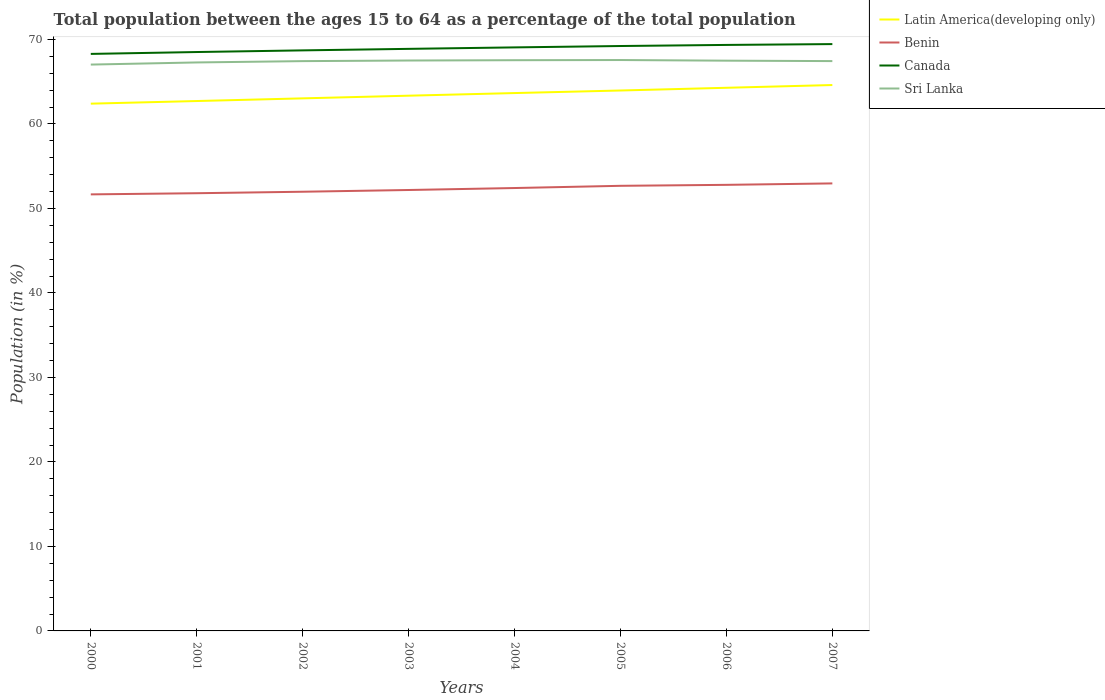Is the number of lines equal to the number of legend labels?
Your response must be concise. Yes. Across all years, what is the maximum percentage of the population ages 15 to 64 in Sri Lanka?
Make the answer very short. 67.02. What is the total percentage of the population ages 15 to 64 in Latin America(developing only) in the graph?
Offer a very short reply. -1.57. What is the difference between the highest and the second highest percentage of the population ages 15 to 64 in Latin America(developing only)?
Give a very brief answer. 2.2. What is the difference between the highest and the lowest percentage of the population ages 15 to 64 in Sri Lanka?
Your answer should be compact. 6. Is the percentage of the population ages 15 to 64 in Sri Lanka strictly greater than the percentage of the population ages 15 to 64 in Benin over the years?
Ensure brevity in your answer.  No. What is the difference between two consecutive major ticks on the Y-axis?
Offer a terse response. 10. Are the values on the major ticks of Y-axis written in scientific E-notation?
Make the answer very short. No. How are the legend labels stacked?
Your answer should be very brief. Vertical. What is the title of the graph?
Provide a succinct answer. Total population between the ages 15 to 64 as a percentage of the total population. Does "Suriname" appear as one of the legend labels in the graph?
Your answer should be very brief. No. What is the Population (in %) of Latin America(developing only) in 2000?
Your answer should be compact. 62.4. What is the Population (in %) in Benin in 2000?
Provide a succinct answer. 51.66. What is the Population (in %) in Canada in 2000?
Offer a very short reply. 68.28. What is the Population (in %) in Sri Lanka in 2000?
Provide a short and direct response. 67.02. What is the Population (in %) in Latin America(developing only) in 2001?
Your answer should be very brief. 62.71. What is the Population (in %) of Benin in 2001?
Your answer should be very brief. 51.8. What is the Population (in %) in Canada in 2001?
Provide a short and direct response. 68.51. What is the Population (in %) in Sri Lanka in 2001?
Ensure brevity in your answer.  67.28. What is the Population (in %) of Latin America(developing only) in 2002?
Provide a succinct answer. 63.02. What is the Population (in %) in Benin in 2002?
Provide a succinct answer. 51.97. What is the Population (in %) in Canada in 2002?
Give a very brief answer. 68.7. What is the Population (in %) of Sri Lanka in 2002?
Keep it short and to the point. 67.43. What is the Population (in %) in Latin America(developing only) in 2003?
Give a very brief answer. 63.34. What is the Population (in %) in Benin in 2003?
Give a very brief answer. 52.18. What is the Population (in %) of Canada in 2003?
Your answer should be compact. 68.88. What is the Population (in %) of Sri Lanka in 2003?
Your answer should be very brief. 67.5. What is the Population (in %) of Latin America(developing only) in 2004?
Provide a succinct answer. 63.65. What is the Population (in %) in Benin in 2004?
Provide a succinct answer. 52.41. What is the Population (in %) of Canada in 2004?
Provide a succinct answer. 69.06. What is the Population (in %) of Sri Lanka in 2004?
Your answer should be very brief. 67.54. What is the Population (in %) of Latin America(developing only) in 2005?
Provide a succinct answer. 63.96. What is the Population (in %) in Benin in 2005?
Provide a succinct answer. 52.67. What is the Population (in %) of Canada in 2005?
Your response must be concise. 69.22. What is the Population (in %) of Sri Lanka in 2005?
Ensure brevity in your answer.  67.56. What is the Population (in %) of Latin America(developing only) in 2006?
Your answer should be compact. 64.28. What is the Population (in %) in Benin in 2006?
Ensure brevity in your answer.  52.79. What is the Population (in %) in Canada in 2006?
Ensure brevity in your answer.  69.35. What is the Population (in %) of Sri Lanka in 2006?
Make the answer very short. 67.48. What is the Population (in %) in Latin America(developing only) in 2007?
Ensure brevity in your answer.  64.6. What is the Population (in %) in Benin in 2007?
Provide a short and direct response. 52.96. What is the Population (in %) of Canada in 2007?
Offer a very short reply. 69.45. What is the Population (in %) of Sri Lanka in 2007?
Your answer should be compact. 67.43. Across all years, what is the maximum Population (in %) in Latin America(developing only)?
Offer a very short reply. 64.6. Across all years, what is the maximum Population (in %) of Benin?
Your answer should be very brief. 52.96. Across all years, what is the maximum Population (in %) in Canada?
Ensure brevity in your answer.  69.45. Across all years, what is the maximum Population (in %) in Sri Lanka?
Give a very brief answer. 67.56. Across all years, what is the minimum Population (in %) in Latin America(developing only)?
Your answer should be compact. 62.4. Across all years, what is the minimum Population (in %) of Benin?
Your response must be concise. 51.66. Across all years, what is the minimum Population (in %) in Canada?
Make the answer very short. 68.28. Across all years, what is the minimum Population (in %) in Sri Lanka?
Give a very brief answer. 67.02. What is the total Population (in %) in Latin America(developing only) in the graph?
Your answer should be very brief. 507.96. What is the total Population (in %) in Benin in the graph?
Offer a terse response. 418.45. What is the total Population (in %) in Canada in the graph?
Make the answer very short. 551.44. What is the total Population (in %) of Sri Lanka in the graph?
Offer a very short reply. 539.25. What is the difference between the Population (in %) in Latin America(developing only) in 2000 and that in 2001?
Keep it short and to the point. -0.31. What is the difference between the Population (in %) of Benin in 2000 and that in 2001?
Make the answer very short. -0.14. What is the difference between the Population (in %) of Canada in 2000 and that in 2001?
Offer a very short reply. -0.22. What is the difference between the Population (in %) in Sri Lanka in 2000 and that in 2001?
Provide a short and direct response. -0.25. What is the difference between the Population (in %) of Latin America(developing only) in 2000 and that in 2002?
Make the answer very short. -0.63. What is the difference between the Population (in %) of Benin in 2000 and that in 2002?
Your response must be concise. -0.31. What is the difference between the Population (in %) in Canada in 2000 and that in 2002?
Keep it short and to the point. -0.42. What is the difference between the Population (in %) in Sri Lanka in 2000 and that in 2002?
Provide a short and direct response. -0.41. What is the difference between the Population (in %) of Latin America(developing only) in 2000 and that in 2003?
Your answer should be compact. -0.94. What is the difference between the Population (in %) of Benin in 2000 and that in 2003?
Offer a terse response. -0.52. What is the difference between the Population (in %) of Canada in 2000 and that in 2003?
Offer a terse response. -0.6. What is the difference between the Population (in %) in Sri Lanka in 2000 and that in 2003?
Provide a succinct answer. -0.48. What is the difference between the Population (in %) in Latin America(developing only) in 2000 and that in 2004?
Your response must be concise. -1.25. What is the difference between the Population (in %) of Benin in 2000 and that in 2004?
Offer a terse response. -0.75. What is the difference between the Population (in %) in Canada in 2000 and that in 2004?
Your answer should be very brief. -0.77. What is the difference between the Population (in %) of Sri Lanka in 2000 and that in 2004?
Give a very brief answer. -0.52. What is the difference between the Population (in %) of Latin America(developing only) in 2000 and that in 2005?
Your answer should be very brief. -1.56. What is the difference between the Population (in %) in Benin in 2000 and that in 2005?
Your answer should be compact. -1.01. What is the difference between the Population (in %) in Canada in 2000 and that in 2005?
Your response must be concise. -0.93. What is the difference between the Population (in %) of Sri Lanka in 2000 and that in 2005?
Provide a succinct answer. -0.54. What is the difference between the Population (in %) in Latin America(developing only) in 2000 and that in 2006?
Give a very brief answer. -1.88. What is the difference between the Population (in %) in Benin in 2000 and that in 2006?
Give a very brief answer. -1.13. What is the difference between the Population (in %) in Canada in 2000 and that in 2006?
Make the answer very short. -1.06. What is the difference between the Population (in %) in Sri Lanka in 2000 and that in 2006?
Your answer should be compact. -0.46. What is the difference between the Population (in %) in Latin America(developing only) in 2000 and that in 2007?
Offer a terse response. -2.2. What is the difference between the Population (in %) in Benin in 2000 and that in 2007?
Make the answer very short. -1.3. What is the difference between the Population (in %) of Canada in 2000 and that in 2007?
Give a very brief answer. -1.16. What is the difference between the Population (in %) of Sri Lanka in 2000 and that in 2007?
Provide a succinct answer. -0.41. What is the difference between the Population (in %) of Latin America(developing only) in 2001 and that in 2002?
Provide a short and direct response. -0.32. What is the difference between the Population (in %) in Benin in 2001 and that in 2002?
Keep it short and to the point. -0.17. What is the difference between the Population (in %) of Canada in 2001 and that in 2002?
Your answer should be compact. -0.2. What is the difference between the Population (in %) in Sri Lanka in 2001 and that in 2002?
Give a very brief answer. -0.15. What is the difference between the Population (in %) in Latin America(developing only) in 2001 and that in 2003?
Keep it short and to the point. -0.63. What is the difference between the Population (in %) in Benin in 2001 and that in 2003?
Your response must be concise. -0.38. What is the difference between the Population (in %) of Canada in 2001 and that in 2003?
Offer a very short reply. -0.37. What is the difference between the Population (in %) in Sri Lanka in 2001 and that in 2003?
Offer a terse response. -0.23. What is the difference between the Population (in %) in Latin America(developing only) in 2001 and that in 2004?
Offer a terse response. -0.94. What is the difference between the Population (in %) of Benin in 2001 and that in 2004?
Keep it short and to the point. -0.61. What is the difference between the Population (in %) of Canada in 2001 and that in 2004?
Your answer should be compact. -0.55. What is the difference between the Population (in %) of Sri Lanka in 2001 and that in 2004?
Keep it short and to the point. -0.26. What is the difference between the Population (in %) of Latin America(developing only) in 2001 and that in 2005?
Make the answer very short. -1.25. What is the difference between the Population (in %) of Benin in 2001 and that in 2005?
Your answer should be compact. -0.88. What is the difference between the Population (in %) in Canada in 2001 and that in 2005?
Give a very brief answer. -0.71. What is the difference between the Population (in %) of Sri Lanka in 2001 and that in 2005?
Provide a short and direct response. -0.28. What is the difference between the Population (in %) in Latin America(developing only) in 2001 and that in 2006?
Make the answer very short. -1.57. What is the difference between the Population (in %) of Benin in 2001 and that in 2006?
Your response must be concise. -0.99. What is the difference between the Population (in %) of Canada in 2001 and that in 2006?
Give a very brief answer. -0.84. What is the difference between the Population (in %) of Sri Lanka in 2001 and that in 2006?
Offer a very short reply. -0.21. What is the difference between the Population (in %) in Latin America(developing only) in 2001 and that in 2007?
Ensure brevity in your answer.  -1.89. What is the difference between the Population (in %) in Benin in 2001 and that in 2007?
Your response must be concise. -1.16. What is the difference between the Population (in %) in Canada in 2001 and that in 2007?
Give a very brief answer. -0.94. What is the difference between the Population (in %) in Sri Lanka in 2001 and that in 2007?
Give a very brief answer. -0.16. What is the difference between the Population (in %) in Latin America(developing only) in 2002 and that in 2003?
Your answer should be very brief. -0.32. What is the difference between the Population (in %) in Benin in 2002 and that in 2003?
Your answer should be compact. -0.2. What is the difference between the Population (in %) in Canada in 2002 and that in 2003?
Keep it short and to the point. -0.18. What is the difference between the Population (in %) in Sri Lanka in 2002 and that in 2003?
Offer a very short reply. -0.07. What is the difference between the Population (in %) of Latin America(developing only) in 2002 and that in 2004?
Your answer should be compact. -0.63. What is the difference between the Population (in %) in Benin in 2002 and that in 2004?
Your response must be concise. -0.44. What is the difference between the Population (in %) in Canada in 2002 and that in 2004?
Make the answer very short. -0.35. What is the difference between the Population (in %) in Sri Lanka in 2002 and that in 2004?
Your answer should be very brief. -0.11. What is the difference between the Population (in %) in Latin America(developing only) in 2002 and that in 2005?
Your answer should be compact. -0.93. What is the difference between the Population (in %) of Benin in 2002 and that in 2005?
Provide a succinct answer. -0.7. What is the difference between the Population (in %) of Canada in 2002 and that in 2005?
Your answer should be very brief. -0.52. What is the difference between the Population (in %) of Sri Lanka in 2002 and that in 2005?
Provide a succinct answer. -0.13. What is the difference between the Population (in %) in Latin America(developing only) in 2002 and that in 2006?
Provide a short and direct response. -1.25. What is the difference between the Population (in %) of Benin in 2002 and that in 2006?
Make the answer very short. -0.82. What is the difference between the Population (in %) of Canada in 2002 and that in 2006?
Your answer should be compact. -0.64. What is the difference between the Population (in %) of Sri Lanka in 2002 and that in 2006?
Provide a succinct answer. -0.05. What is the difference between the Population (in %) of Latin America(developing only) in 2002 and that in 2007?
Provide a short and direct response. -1.58. What is the difference between the Population (in %) of Benin in 2002 and that in 2007?
Your answer should be compact. -0.99. What is the difference between the Population (in %) of Canada in 2002 and that in 2007?
Keep it short and to the point. -0.74. What is the difference between the Population (in %) in Sri Lanka in 2002 and that in 2007?
Offer a terse response. -0. What is the difference between the Population (in %) in Latin America(developing only) in 2003 and that in 2004?
Ensure brevity in your answer.  -0.31. What is the difference between the Population (in %) in Benin in 2003 and that in 2004?
Provide a short and direct response. -0.23. What is the difference between the Population (in %) in Canada in 2003 and that in 2004?
Provide a succinct answer. -0.17. What is the difference between the Population (in %) of Sri Lanka in 2003 and that in 2004?
Ensure brevity in your answer.  -0.04. What is the difference between the Population (in %) in Latin America(developing only) in 2003 and that in 2005?
Offer a very short reply. -0.61. What is the difference between the Population (in %) in Benin in 2003 and that in 2005?
Give a very brief answer. -0.5. What is the difference between the Population (in %) of Canada in 2003 and that in 2005?
Ensure brevity in your answer.  -0.34. What is the difference between the Population (in %) of Sri Lanka in 2003 and that in 2005?
Your answer should be compact. -0.06. What is the difference between the Population (in %) in Latin America(developing only) in 2003 and that in 2006?
Provide a short and direct response. -0.94. What is the difference between the Population (in %) in Benin in 2003 and that in 2006?
Offer a very short reply. -0.61. What is the difference between the Population (in %) in Canada in 2003 and that in 2006?
Give a very brief answer. -0.47. What is the difference between the Population (in %) of Sri Lanka in 2003 and that in 2006?
Your answer should be very brief. 0.02. What is the difference between the Population (in %) of Latin America(developing only) in 2003 and that in 2007?
Your answer should be compact. -1.26. What is the difference between the Population (in %) in Benin in 2003 and that in 2007?
Provide a short and direct response. -0.78. What is the difference between the Population (in %) of Canada in 2003 and that in 2007?
Provide a short and direct response. -0.57. What is the difference between the Population (in %) of Sri Lanka in 2003 and that in 2007?
Your response must be concise. 0.07. What is the difference between the Population (in %) of Latin America(developing only) in 2004 and that in 2005?
Ensure brevity in your answer.  -0.3. What is the difference between the Population (in %) of Benin in 2004 and that in 2005?
Offer a very short reply. -0.26. What is the difference between the Population (in %) of Canada in 2004 and that in 2005?
Offer a terse response. -0.16. What is the difference between the Population (in %) in Sri Lanka in 2004 and that in 2005?
Keep it short and to the point. -0.02. What is the difference between the Population (in %) in Latin America(developing only) in 2004 and that in 2006?
Your answer should be compact. -0.63. What is the difference between the Population (in %) in Benin in 2004 and that in 2006?
Give a very brief answer. -0.38. What is the difference between the Population (in %) in Canada in 2004 and that in 2006?
Provide a short and direct response. -0.29. What is the difference between the Population (in %) of Sri Lanka in 2004 and that in 2006?
Keep it short and to the point. 0.06. What is the difference between the Population (in %) of Latin America(developing only) in 2004 and that in 2007?
Make the answer very short. -0.95. What is the difference between the Population (in %) of Benin in 2004 and that in 2007?
Offer a very short reply. -0.55. What is the difference between the Population (in %) in Canada in 2004 and that in 2007?
Offer a very short reply. -0.39. What is the difference between the Population (in %) of Sri Lanka in 2004 and that in 2007?
Your response must be concise. 0.11. What is the difference between the Population (in %) in Latin America(developing only) in 2005 and that in 2006?
Your answer should be compact. -0.32. What is the difference between the Population (in %) of Benin in 2005 and that in 2006?
Your answer should be compact. -0.12. What is the difference between the Population (in %) in Canada in 2005 and that in 2006?
Give a very brief answer. -0.13. What is the difference between the Population (in %) of Sri Lanka in 2005 and that in 2006?
Your answer should be very brief. 0.08. What is the difference between the Population (in %) in Latin America(developing only) in 2005 and that in 2007?
Give a very brief answer. -0.65. What is the difference between the Population (in %) of Benin in 2005 and that in 2007?
Make the answer very short. -0.28. What is the difference between the Population (in %) of Canada in 2005 and that in 2007?
Offer a terse response. -0.23. What is the difference between the Population (in %) of Sri Lanka in 2005 and that in 2007?
Provide a succinct answer. 0.13. What is the difference between the Population (in %) in Latin America(developing only) in 2006 and that in 2007?
Ensure brevity in your answer.  -0.32. What is the difference between the Population (in %) of Benin in 2006 and that in 2007?
Your answer should be very brief. -0.17. What is the difference between the Population (in %) of Canada in 2006 and that in 2007?
Ensure brevity in your answer.  -0.1. What is the difference between the Population (in %) in Sri Lanka in 2006 and that in 2007?
Make the answer very short. 0.05. What is the difference between the Population (in %) of Latin America(developing only) in 2000 and the Population (in %) of Benin in 2001?
Offer a terse response. 10.6. What is the difference between the Population (in %) of Latin America(developing only) in 2000 and the Population (in %) of Canada in 2001?
Your answer should be very brief. -6.11. What is the difference between the Population (in %) in Latin America(developing only) in 2000 and the Population (in %) in Sri Lanka in 2001?
Make the answer very short. -4.88. What is the difference between the Population (in %) in Benin in 2000 and the Population (in %) in Canada in 2001?
Your response must be concise. -16.85. What is the difference between the Population (in %) of Benin in 2000 and the Population (in %) of Sri Lanka in 2001?
Your response must be concise. -15.61. What is the difference between the Population (in %) of Canada in 2000 and the Population (in %) of Sri Lanka in 2001?
Provide a succinct answer. 1.01. What is the difference between the Population (in %) in Latin America(developing only) in 2000 and the Population (in %) in Benin in 2002?
Ensure brevity in your answer.  10.42. What is the difference between the Population (in %) in Latin America(developing only) in 2000 and the Population (in %) in Canada in 2002?
Make the answer very short. -6.3. What is the difference between the Population (in %) of Latin America(developing only) in 2000 and the Population (in %) of Sri Lanka in 2002?
Your answer should be compact. -5.03. What is the difference between the Population (in %) in Benin in 2000 and the Population (in %) in Canada in 2002?
Keep it short and to the point. -17.04. What is the difference between the Population (in %) of Benin in 2000 and the Population (in %) of Sri Lanka in 2002?
Give a very brief answer. -15.77. What is the difference between the Population (in %) of Canada in 2000 and the Population (in %) of Sri Lanka in 2002?
Ensure brevity in your answer.  0.85. What is the difference between the Population (in %) in Latin America(developing only) in 2000 and the Population (in %) in Benin in 2003?
Your answer should be compact. 10.22. What is the difference between the Population (in %) in Latin America(developing only) in 2000 and the Population (in %) in Canada in 2003?
Make the answer very short. -6.48. What is the difference between the Population (in %) of Latin America(developing only) in 2000 and the Population (in %) of Sri Lanka in 2003?
Ensure brevity in your answer.  -5.11. What is the difference between the Population (in %) of Benin in 2000 and the Population (in %) of Canada in 2003?
Make the answer very short. -17.22. What is the difference between the Population (in %) of Benin in 2000 and the Population (in %) of Sri Lanka in 2003?
Give a very brief answer. -15.84. What is the difference between the Population (in %) in Canada in 2000 and the Population (in %) in Sri Lanka in 2003?
Your response must be concise. 0.78. What is the difference between the Population (in %) of Latin America(developing only) in 2000 and the Population (in %) of Benin in 2004?
Your answer should be very brief. 9.99. What is the difference between the Population (in %) of Latin America(developing only) in 2000 and the Population (in %) of Canada in 2004?
Give a very brief answer. -6.66. What is the difference between the Population (in %) of Latin America(developing only) in 2000 and the Population (in %) of Sri Lanka in 2004?
Provide a short and direct response. -5.14. What is the difference between the Population (in %) of Benin in 2000 and the Population (in %) of Canada in 2004?
Offer a very short reply. -17.39. What is the difference between the Population (in %) in Benin in 2000 and the Population (in %) in Sri Lanka in 2004?
Offer a very short reply. -15.88. What is the difference between the Population (in %) in Canada in 2000 and the Population (in %) in Sri Lanka in 2004?
Keep it short and to the point. 0.74. What is the difference between the Population (in %) in Latin America(developing only) in 2000 and the Population (in %) in Benin in 2005?
Give a very brief answer. 9.72. What is the difference between the Population (in %) of Latin America(developing only) in 2000 and the Population (in %) of Canada in 2005?
Make the answer very short. -6.82. What is the difference between the Population (in %) in Latin America(developing only) in 2000 and the Population (in %) in Sri Lanka in 2005?
Give a very brief answer. -5.16. What is the difference between the Population (in %) in Benin in 2000 and the Population (in %) in Canada in 2005?
Ensure brevity in your answer.  -17.56. What is the difference between the Population (in %) of Benin in 2000 and the Population (in %) of Sri Lanka in 2005?
Ensure brevity in your answer.  -15.9. What is the difference between the Population (in %) in Canada in 2000 and the Population (in %) in Sri Lanka in 2005?
Keep it short and to the point. 0.72. What is the difference between the Population (in %) in Latin America(developing only) in 2000 and the Population (in %) in Benin in 2006?
Ensure brevity in your answer.  9.61. What is the difference between the Population (in %) in Latin America(developing only) in 2000 and the Population (in %) in Canada in 2006?
Keep it short and to the point. -6.95. What is the difference between the Population (in %) in Latin America(developing only) in 2000 and the Population (in %) in Sri Lanka in 2006?
Offer a very short reply. -5.09. What is the difference between the Population (in %) of Benin in 2000 and the Population (in %) of Canada in 2006?
Make the answer very short. -17.69. What is the difference between the Population (in %) in Benin in 2000 and the Population (in %) in Sri Lanka in 2006?
Ensure brevity in your answer.  -15.82. What is the difference between the Population (in %) in Latin America(developing only) in 2000 and the Population (in %) in Benin in 2007?
Your answer should be compact. 9.44. What is the difference between the Population (in %) of Latin America(developing only) in 2000 and the Population (in %) of Canada in 2007?
Give a very brief answer. -7.05. What is the difference between the Population (in %) of Latin America(developing only) in 2000 and the Population (in %) of Sri Lanka in 2007?
Ensure brevity in your answer.  -5.04. What is the difference between the Population (in %) in Benin in 2000 and the Population (in %) in Canada in 2007?
Provide a short and direct response. -17.79. What is the difference between the Population (in %) of Benin in 2000 and the Population (in %) of Sri Lanka in 2007?
Keep it short and to the point. -15.77. What is the difference between the Population (in %) of Canada in 2000 and the Population (in %) of Sri Lanka in 2007?
Keep it short and to the point. 0.85. What is the difference between the Population (in %) of Latin America(developing only) in 2001 and the Population (in %) of Benin in 2002?
Keep it short and to the point. 10.73. What is the difference between the Population (in %) of Latin America(developing only) in 2001 and the Population (in %) of Canada in 2002?
Your answer should be very brief. -6. What is the difference between the Population (in %) in Latin America(developing only) in 2001 and the Population (in %) in Sri Lanka in 2002?
Ensure brevity in your answer.  -4.72. What is the difference between the Population (in %) in Benin in 2001 and the Population (in %) in Canada in 2002?
Keep it short and to the point. -16.9. What is the difference between the Population (in %) in Benin in 2001 and the Population (in %) in Sri Lanka in 2002?
Your response must be concise. -15.63. What is the difference between the Population (in %) in Canada in 2001 and the Population (in %) in Sri Lanka in 2002?
Offer a very short reply. 1.08. What is the difference between the Population (in %) in Latin America(developing only) in 2001 and the Population (in %) in Benin in 2003?
Your response must be concise. 10.53. What is the difference between the Population (in %) of Latin America(developing only) in 2001 and the Population (in %) of Canada in 2003?
Keep it short and to the point. -6.17. What is the difference between the Population (in %) in Latin America(developing only) in 2001 and the Population (in %) in Sri Lanka in 2003?
Make the answer very short. -4.8. What is the difference between the Population (in %) in Benin in 2001 and the Population (in %) in Canada in 2003?
Provide a short and direct response. -17.08. What is the difference between the Population (in %) in Benin in 2001 and the Population (in %) in Sri Lanka in 2003?
Your response must be concise. -15.7. What is the difference between the Population (in %) in Latin America(developing only) in 2001 and the Population (in %) in Benin in 2004?
Provide a succinct answer. 10.3. What is the difference between the Population (in %) in Latin America(developing only) in 2001 and the Population (in %) in Canada in 2004?
Your answer should be compact. -6.35. What is the difference between the Population (in %) in Latin America(developing only) in 2001 and the Population (in %) in Sri Lanka in 2004?
Ensure brevity in your answer.  -4.83. What is the difference between the Population (in %) of Benin in 2001 and the Population (in %) of Canada in 2004?
Your answer should be compact. -17.26. What is the difference between the Population (in %) of Benin in 2001 and the Population (in %) of Sri Lanka in 2004?
Keep it short and to the point. -15.74. What is the difference between the Population (in %) in Canada in 2001 and the Population (in %) in Sri Lanka in 2004?
Offer a very short reply. 0.97. What is the difference between the Population (in %) in Latin America(developing only) in 2001 and the Population (in %) in Benin in 2005?
Your response must be concise. 10.03. What is the difference between the Population (in %) in Latin America(developing only) in 2001 and the Population (in %) in Canada in 2005?
Give a very brief answer. -6.51. What is the difference between the Population (in %) in Latin America(developing only) in 2001 and the Population (in %) in Sri Lanka in 2005?
Ensure brevity in your answer.  -4.85. What is the difference between the Population (in %) of Benin in 2001 and the Population (in %) of Canada in 2005?
Offer a terse response. -17.42. What is the difference between the Population (in %) in Benin in 2001 and the Population (in %) in Sri Lanka in 2005?
Provide a short and direct response. -15.76. What is the difference between the Population (in %) of Canada in 2001 and the Population (in %) of Sri Lanka in 2005?
Ensure brevity in your answer.  0.95. What is the difference between the Population (in %) of Latin America(developing only) in 2001 and the Population (in %) of Benin in 2006?
Ensure brevity in your answer.  9.92. What is the difference between the Population (in %) of Latin America(developing only) in 2001 and the Population (in %) of Canada in 2006?
Your answer should be compact. -6.64. What is the difference between the Population (in %) of Latin America(developing only) in 2001 and the Population (in %) of Sri Lanka in 2006?
Your response must be concise. -4.78. What is the difference between the Population (in %) in Benin in 2001 and the Population (in %) in Canada in 2006?
Ensure brevity in your answer.  -17.55. What is the difference between the Population (in %) in Benin in 2001 and the Population (in %) in Sri Lanka in 2006?
Provide a short and direct response. -15.68. What is the difference between the Population (in %) in Canada in 2001 and the Population (in %) in Sri Lanka in 2006?
Your answer should be very brief. 1.02. What is the difference between the Population (in %) in Latin America(developing only) in 2001 and the Population (in %) in Benin in 2007?
Your response must be concise. 9.75. What is the difference between the Population (in %) of Latin America(developing only) in 2001 and the Population (in %) of Canada in 2007?
Your answer should be very brief. -6.74. What is the difference between the Population (in %) in Latin America(developing only) in 2001 and the Population (in %) in Sri Lanka in 2007?
Ensure brevity in your answer.  -4.73. What is the difference between the Population (in %) of Benin in 2001 and the Population (in %) of Canada in 2007?
Offer a terse response. -17.65. What is the difference between the Population (in %) of Benin in 2001 and the Population (in %) of Sri Lanka in 2007?
Offer a terse response. -15.63. What is the difference between the Population (in %) of Canada in 2001 and the Population (in %) of Sri Lanka in 2007?
Keep it short and to the point. 1.07. What is the difference between the Population (in %) of Latin America(developing only) in 2002 and the Population (in %) of Benin in 2003?
Offer a terse response. 10.85. What is the difference between the Population (in %) in Latin America(developing only) in 2002 and the Population (in %) in Canada in 2003?
Keep it short and to the point. -5.86. What is the difference between the Population (in %) in Latin America(developing only) in 2002 and the Population (in %) in Sri Lanka in 2003?
Your response must be concise. -4.48. What is the difference between the Population (in %) of Benin in 2002 and the Population (in %) of Canada in 2003?
Offer a very short reply. -16.91. What is the difference between the Population (in %) in Benin in 2002 and the Population (in %) in Sri Lanka in 2003?
Your answer should be compact. -15.53. What is the difference between the Population (in %) of Canada in 2002 and the Population (in %) of Sri Lanka in 2003?
Offer a terse response. 1.2. What is the difference between the Population (in %) in Latin America(developing only) in 2002 and the Population (in %) in Benin in 2004?
Your answer should be very brief. 10.61. What is the difference between the Population (in %) in Latin America(developing only) in 2002 and the Population (in %) in Canada in 2004?
Make the answer very short. -6.03. What is the difference between the Population (in %) of Latin America(developing only) in 2002 and the Population (in %) of Sri Lanka in 2004?
Your answer should be very brief. -4.52. What is the difference between the Population (in %) in Benin in 2002 and the Population (in %) in Canada in 2004?
Offer a very short reply. -17.08. What is the difference between the Population (in %) in Benin in 2002 and the Population (in %) in Sri Lanka in 2004?
Your answer should be compact. -15.57. What is the difference between the Population (in %) in Canada in 2002 and the Population (in %) in Sri Lanka in 2004?
Provide a short and direct response. 1.16. What is the difference between the Population (in %) in Latin America(developing only) in 2002 and the Population (in %) in Benin in 2005?
Offer a terse response. 10.35. What is the difference between the Population (in %) in Latin America(developing only) in 2002 and the Population (in %) in Canada in 2005?
Keep it short and to the point. -6.19. What is the difference between the Population (in %) in Latin America(developing only) in 2002 and the Population (in %) in Sri Lanka in 2005?
Provide a short and direct response. -4.54. What is the difference between the Population (in %) of Benin in 2002 and the Population (in %) of Canada in 2005?
Keep it short and to the point. -17.24. What is the difference between the Population (in %) in Benin in 2002 and the Population (in %) in Sri Lanka in 2005?
Your answer should be very brief. -15.59. What is the difference between the Population (in %) of Canada in 2002 and the Population (in %) of Sri Lanka in 2005?
Provide a short and direct response. 1.14. What is the difference between the Population (in %) in Latin America(developing only) in 2002 and the Population (in %) in Benin in 2006?
Ensure brevity in your answer.  10.23. What is the difference between the Population (in %) in Latin America(developing only) in 2002 and the Population (in %) in Canada in 2006?
Make the answer very short. -6.32. What is the difference between the Population (in %) of Latin America(developing only) in 2002 and the Population (in %) of Sri Lanka in 2006?
Keep it short and to the point. -4.46. What is the difference between the Population (in %) in Benin in 2002 and the Population (in %) in Canada in 2006?
Your response must be concise. -17.37. What is the difference between the Population (in %) in Benin in 2002 and the Population (in %) in Sri Lanka in 2006?
Give a very brief answer. -15.51. What is the difference between the Population (in %) in Canada in 2002 and the Population (in %) in Sri Lanka in 2006?
Offer a terse response. 1.22. What is the difference between the Population (in %) of Latin America(developing only) in 2002 and the Population (in %) of Benin in 2007?
Ensure brevity in your answer.  10.07. What is the difference between the Population (in %) in Latin America(developing only) in 2002 and the Population (in %) in Canada in 2007?
Give a very brief answer. -6.42. What is the difference between the Population (in %) of Latin America(developing only) in 2002 and the Population (in %) of Sri Lanka in 2007?
Keep it short and to the point. -4.41. What is the difference between the Population (in %) of Benin in 2002 and the Population (in %) of Canada in 2007?
Offer a terse response. -17.47. What is the difference between the Population (in %) of Benin in 2002 and the Population (in %) of Sri Lanka in 2007?
Offer a terse response. -15.46. What is the difference between the Population (in %) in Canada in 2002 and the Population (in %) in Sri Lanka in 2007?
Ensure brevity in your answer.  1.27. What is the difference between the Population (in %) of Latin America(developing only) in 2003 and the Population (in %) of Benin in 2004?
Provide a succinct answer. 10.93. What is the difference between the Population (in %) in Latin America(developing only) in 2003 and the Population (in %) in Canada in 2004?
Ensure brevity in your answer.  -5.71. What is the difference between the Population (in %) of Latin America(developing only) in 2003 and the Population (in %) of Sri Lanka in 2004?
Keep it short and to the point. -4.2. What is the difference between the Population (in %) in Benin in 2003 and the Population (in %) in Canada in 2004?
Provide a succinct answer. -16.88. What is the difference between the Population (in %) of Benin in 2003 and the Population (in %) of Sri Lanka in 2004?
Provide a succinct answer. -15.36. What is the difference between the Population (in %) in Canada in 2003 and the Population (in %) in Sri Lanka in 2004?
Provide a succinct answer. 1.34. What is the difference between the Population (in %) of Latin America(developing only) in 2003 and the Population (in %) of Benin in 2005?
Make the answer very short. 10.67. What is the difference between the Population (in %) in Latin America(developing only) in 2003 and the Population (in %) in Canada in 2005?
Provide a short and direct response. -5.88. What is the difference between the Population (in %) of Latin America(developing only) in 2003 and the Population (in %) of Sri Lanka in 2005?
Offer a very short reply. -4.22. What is the difference between the Population (in %) of Benin in 2003 and the Population (in %) of Canada in 2005?
Your response must be concise. -17.04. What is the difference between the Population (in %) of Benin in 2003 and the Population (in %) of Sri Lanka in 2005?
Your answer should be compact. -15.38. What is the difference between the Population (in %) of Canada in 2003 and the Population (in %) of Sri Lanka in 2005?
Your answer should be compact. 1.32. What is the difference between the Population (in %) of Latin America(developing only) in 2003 and the Population (in %) of Benin in 2006?
Provide a short and direct response. 10.55. What is the difference between the Population (in %) in Latin America(developing only) in 2003 and the Population (in %) in Canada in 2006?
Make the answer very short. -6.01. What is the difference between the Population (in %) of Latin America(developing only) in 2003 and the Population (in %) of Sri Lanka in 2006?
Provide a succinct answer. -4.14. What is the difference between the Population (in %) of Benin in 2003 and the Population (in %) of Canada in 2006?
Keep it short and to the point. -17.17. What is the difference between the Population (in %) of Benin in 2003 and the Population (in %) of Sri Lanka in 2006?
Offer a very short reply. -15.31. What is the difference between the Population (in %) of Canada in 2003 and the Population (in %) of Sri Lanka in 2006?
Make the answer very short. 1.4. What is the difference between the Population (in %) in Latin America(developing only) in 2003 and the Population (in %) in Benin in 2007?
Your response must be concise. 10.38. What is the difference between the Population (in %) in Latin America(developing only) in 2003 and the Population (in %) in Canada in 2007?
Offer a terse response. -6.11. What is the difference between the Population (in %) of Latin America(developing only) in 2003 and the Population (in %) of Sri Lanka in 2007?
Make the answer very short. -4.09. What is the difference between the Population (in %) of Benin in 2003 and the Population (in %) of Canada in 2007?
Your answer should be very brief. -17.27. What is the difference between the Population (in %) in Benin in 2003 and the Population (in %) in Sri Lanka in 2007?
Keep it short and to the point. -15.26. What is the difference between the Population (in %) in Canada in 2003 and the Population (in %) in Sri Lanka in 2007?
Your response must be concise. 1.45. What is the difference between the Population (in %) in Latin America(developing only) in 2004 and the Population (in %) in Benin in 2005?
Your answer should be compact. 10.98. What is the difference between the Population (in %) of Latin America(developing only) in 2004 and the Population (in %) of Canada in 2005?
Offer a very short reply. -5.57. What is the difference between the Population (in %) in Latin America(developing only) in 2004 and the Population (in %) in Sri Lanka in 2005?
Keep it short and to the point. -3.91. What is the difference between the Population (in %) in Benin in 2004 and the Population (in %) in Canada in 2005?
Ensure brevity in your answer.  -16.81. What is the difference between the Population (in %) of Benin in 2004 and the Population (in %) of Sri Lanka in 2005?
Ensure brevity in your answer.  -15.15. What is the difference between the Population (in %) of Canada in 2004 and the Population (in %) of Sri Lanka in 2005?
Your answer should be compact. 1.5. What is the difference between the Population (in %) in Latin America(developing only) in 2004 and the Population (in %) in Benin in 2006?
Your answer should be compact. 10.86. What is the difference between the Population (in %) in Latin America(developing only) in 2004 and the Population (in %) in Canada in 2006?
Keep it short and to the point. -5.7. What is the difference between the Population (in %) of Latin America(developing only) in 2004 and the Population (in %) of Sri Lanka in 2006?
Offer a very short reply. -3.83. What is the difference between the Population (in %) in Benin in 2004 and the Population (in %) in Canada in 2006?
Offer a very short reply. -16.94. What is the difference between the Population (in %) of Benin in 2004 and the Population (in %) of Sri Lanka in 2006?
Make the answer very short. -15.07. What is the difference between the Population (in %) in Canada in 2004 and the Population (in %) in Sri Lanka in 2006?
Keep it short and to the point. 1.57. What is the difference between the Population (in %) of Latin America(developing only) in 2004 and the Population (in %) of Benin in 2007?
Ensure brevity in your answer.  10.69. What is the difference between the Population (in %) of Latin America(developing only) in 2004 and the Population (in %) of Canada in 2007?
Offer a terse response. -5.8. What is the difference between the Population (in %) in Latin America(developing only) in 2004 and the Population (in %) in Sri Lanka in 2007?
Provide a succinct answer. -3.78. What is the difference between the Population (in %) in Benin in 2004 and the Population (in %) in Canada in 2007?
Your answer should be compact. -17.03. What is the difference between the Population (in %) of Benin in 2004 and the Population (in %) of Sri Lanka in 2007?
Ensure brevity in your answer.  -15.02. What is the difference between the Population (in %) of Canada in 2004 and the Population (in %) of Sri Lanka in 2007?
Offer a terse response. 1.62. What is the difference between the Population (in %) of Latin America(developing only) in 2005 and the Population (in %) of Benin in 2006?
Offer a terse response. 11.16. What is the difference between the Population (in %) of Latin America(developing only) in 2005 and the Population (in %) of Canada in 2006?
Make the answer very short. -5.39. What is the difference between the Population (in %) in Latin America(developing only) in 2005 and the Population (in %) in Sri Lanka in 2006?
Your answer should be compact. -3.53. What is the difference between the Population (in %) of Benin in 2005 and the Population (in %) of Canada in 2006?
Give a very brief answer. -16.67. What is the difference between the Population (in %) in Benin in 2005 and the Population (in %) in Sri Lanka in 2006?
Keep it short and to the point. -14.81. What is the difference between the Population (in %) of Canada in 2005 and the Population (in %) of Sri Lanka in 2006?
Provide a short and direct response. 1.73. What is the difference between the Population (in %) of Latin America(developing only) in 2005 and the Population (in %) of Benin in 2007?
Your answer should be very brief. 11. What is the difference between the Population (in %) in Latin America(developing only) in 2005 and the Population (in %) in Canada in 2007?
Provide a succinct answer. -5.49. What is the difference between the Population (in %) of Latin America(developing only) in 2005 and the Population (in %) of Sri Lanka in 2007?
Make the answer very short. -3.48. What is the difference between the Population (in %) in Benin in 2005 and the Population (in %) in Canada in 2007?
Your response must be concise. -16.77. What is the difference between the Population (in %) in Benin in 2005 and the Population (in %) in Sri Lanka in 2007?
Offer a very short reply. -14.76. What is the difference between the Population (in %) of Canada in 2005 and the Population (in %) of Sri Lanka in 2007?
Your answer should be very brief. 1.78. What is the difference between the Population (in %) in Latin America(developing only) in 2006 and the Population (in %) in Benin in 2007?
Your response must be concise. 11.32. What is the difference between the Population (in %) of Latin America(developing only) in 2006 and the Population (in %) of Canada in 2007?
Offer a terse response. -5.17. What is the difference between the Population (in %) in Latin America(developing only) in 2006 and the Population (in %) in Sri Lanka in 2007?
Make the answer very short. -3.16. What is the difference between the Population (in %) in Benin in 2006 and the Population (in %) in Canada in 2007?
Make the answer very short. -16.66. What is the difference between the Population (in %) in Benin in 2006 and the Population (in %) in Sri Lanka in 2007?
Offer a terse response. -14.64. What is the difference between the Population (in %) in Canada in 2006 and the Population (in %) in Sri Lanka in 2007?
Your answer should be compact. 1.91. What is the average Population (in %) in Latin America(developing only) per year?
Keep it short and to the point. 63.49. What is the average Population (in %) in Benin per year?
Provide a succinct answer. 52.31. What is the average Population (in %) of Canada per year?
Your response must be concise. 68.93. What is the average Population (in %) of Sri Lanka per year?
Your answer should be compact. 67.41. In the year 2000, what is the difference between the Population (in %) of Latin America(developing only) and Population (in %) of Benin?
Provide a succinct answer. 10.74. In the year 2000, what is the difference between the Population (in %) of Latin America(developing only) and Population (in %) of Canada?
Provide a short and direct response. -5.89. In the year 2000, what is the difference between the Population (in %) in Latin America(developing only) and Population (in %) in Sri Lanka?
Give a very brief answer. -4.62. In the year 2000, what is the difference between the Population (in %) of Benin and Population (in %) of Canada?
Offer a very short reply. -16.62. In the year 2000, what is the difference between the Population (in %) in Benin and Population (in %) in Sri Lanka?
Ensure brevity in your answer.  -15.36. In the year 2000, what is the difference between the Population (in %) in Canada and Population (in %) in Sri Lanka?
Give a very brief answer. 1.26. In the year 2001, what is the difference between the Population (in %) of Latin America(developing only) and Population (in %) of Benin?
Keep it short and to the point. 10.91. In the year 2001, what is the difference between the Population (in %) of Latin America(developing only) and Population (in %) of Canada?
Keep it short and to the point. -5.8. In the year 2001, what is the difference between the Population (in %) of Latin America(developing only) and Population (in %) of Sri Lanka?
Your response must be concise. -4.57. In the year 2001, what is the difference between the Population (in %) in Benin and Population (in %) in Canada?
Your answer should be compact. -16.71. In the year 2001, what is the difference between the Population (in %) of Benin and Population (in %) of Sri Lanka?
Your response must be concise. -15.48. In the year 2001, what is the difference between the Population (in %) of Canada and Population (in %) of Sri Lanka?
Your answer should be compact. 1.23. In the year 2002, what is the difference between the Population (in %) in Latin America(developing only) and Population (in %) in Benin?
Offer a very short reply. 11.05. In the year 2002, what is the difference between the Population (in %) in Latin America(developing only) and Population (in %) in Canada?
Provide a short and direct response. -5.68. In the year 2002, what is the difference between the Population (in %) in Latin America(developing only) and Population (in %) in Sri Lanka?
Provide a short and direct response. -4.41. In the year 2002, what is the difference between the Population (in %) in Benin and Population (in %) in Canada?
Keep it short and to the point. -16.73. In the year 2002, what is the difference between the Population (in %) of Benin and Population (in %) of Sri Lanka?
Ensure brevity in your answer.  -15.46. In the year 2002, what is the difference between the Population (in %) of Canada and Population (in %) of Sri Lanka?
Ensure brevity in your answer.  1.27. In the year 2003, what is the difference between the Population (in %) of Latin America(developing only) and Population (in %) of Benin?
Provide a succinct answer. 11.16. In the year 2003, what is the difference between the Population (in %) in Latin America(developing only) and Population (in %) in Canada?
Offer a very short reply. -5.54. In the year 2003, what is the difference between the Population (in %) of Latin America(developing only) and Population (in %) of Sri Lanka?
Your answer should be very brief. -4.16. In the year 2003, what is the difference between the Population (in %) in Benin and Population (in %) in Canada?
Ensure brevity in your answer.  -16.7. In the year 2003, what is the difference between the Population (in %) of Benin and Population (in %) of Sri Lanka?
Ensure brevity in your answer.  -15.32. In the year 2003, what is the difference between the Population (in %) in Canada and Population (in %) in Sri Lanka?
Provide a short and direct response. 1.38. In the year 2004, what is the difference between the Population (in %) in Latin America(developing only) and Population (in %) in Benin?
Your response must be concise. 11.24. In the year 2004, what is the difference between the Population (in %) in Latin America(developing only) and Population (in %) in Canada?
Keep it short and to the point. -5.4. In the year 2004, what is the difference between the Population (in %) of Latin America(developing only) and Population (in %) of Sri Lanka?
Your answer should be very brief. -3.89. In the year 2004, what is the difference between the Population (in %) of Benin and Population (in %) of Canada?
Your answer should be compact. -16.64. In the year 2004, what is the difference between the Population (in %) in Benin and Population (in %) in Sri Lanka?
Ensure brevity in your answer.  -15.13. In the year 2004, what is the difference between the Population (in %) of Canada and Population (in %) of Sri Lanka?
Give a very brief answer. 1.52. In the year 2005, what is the difference between the Population (in %) in Latin America(developing only) and Population (in %) in Benin?
Make the answer very short. 11.28. In the year 2005, what is the difference between the Population (in %) of Latin America(developing only) and Population (in %) of Canada?
Ensure brevity in your answer.  -5.26. In the year 2005, what is the difference between the Population (in %) of Latin America(developing only) and Population (in %) of Sri Lanka?
Ensure brevity in your answer.  -3.61. In the year 2005, what is the difference between the Population (in %) in Benin and Population (in %) in Canada?
Offer a terse response. -16.54. In the year 2005, what is the difference between the Population (in %) of Benin and Population (in %) of Sri Lanka?
Keep it short and to the point. -14.89. In the year 2005, what is the difference between the Population (in %) of Canada and Population (in %) of Sri Lanka?
Give a very brief answer. 1.66. In the year 2006, what is the difference between the Population (in %) of Latin America(developing only) and Population (in %) of Benin?
Keep it short and to the point. 11.49. In the year 2006, what is the difference between the Population (in %) in Latin America(developing only) and Population (in %) in Canada?
Give a very brief answer. -5.07. In the year 2006, what is the difference between the Population (in %) in Latin America(developing only) and Population (in %) in Sri Lanka?
Your answer should be compact. -3.21. In the year 2006, what is the difference between the Population (in %) in Benin and Population (in %) in Canada?
Your answer should be compact. -16.56. In the year 2006, what is the difference between the Population (in %) in Benin and Population (in %) in Sri Lanka?
Your answer should be compact. -14.69. In the year 2006, what is the difference between the Population (in %) of Canada and Population (in %) of Sri Lanka?
Keep it short and to the point. 1.86. In the year 2007, what is the difference between the Population (in %) of Latin America(developing only) and Population (in %) of Benin?
Provide a short and direct response. 11.64. In the year 2007, what is the difference between the Population (in %) of Latin America(developing only) and Population (in %) of Canada?
Keep it short and to the point. -4.85. In the year 2007, what is the difference between the Population (in %) in Latin America(developing only) and Population (in %) in Sri Lanka?
Provide a succinct answer. -2.83. In the year 2007, what is the difference between the Population (in %) of Benin and Population (in %) of Canada?
Offer a terse response. -16.49. In the year 2007, what is the difference between the Population (in %) of Benin and Population (in %) of Sri Lanka?
Ensure brevity in your answer.  -14.47. In the year 2007, what is the difference between the Population (in %) in Canada and Population (in %) in Sri Lanka?
Ensure brevity in your answer.  2.01. What is the ratio of the Population (in %) of Benin in 2000 to that in 2001?
Ensure brevity in your answer.  1. What is the ratio of the Population (in %) of Latin America(developing only) in 2000 to that in 2002?
Your answer should be compact. 0.99. What is the ratio of the Population (in %) of Sri Lanka in 2000 to that in 2002?
Provide a succinct answer. 0.99. What is the ratio of the Population (in %) in Latin America(developing only) in 2000 to that in 2003?
Give a very brief answer. 0.99. What is the ratio of the Population (in %) in Canada in 2000 to that in 2003?
Your answer should be compact. 0.99. What is the ratio of the Population (in %) of Sri Lanka in 2000 to that in 2003?
Keep it short and to the point. 0.99. What is the ratio of the Population (in %) of Latin America(developing only) in 2000 to that in 2004?
Keep it short and to the point. 0.98. What is the ratio of the Population (in %) of Benin in 2000 to that in 2004?
Your response must be concise. 0.99. What is the ratio of the Population (in %) of Latin America(developing only) in 2000 to that in 2005?
Your answer should be very brief. 0.98. What is the ratio of the Population (in %) of Benin in 2000 to that in 2005?
Ensure brevity in your answer.  0.98. What is the ratio of the Population (in %) of Canada in 2000 to that in 2005?
Provide a short and direct response. 0.99. What is the ratio of the Population (in %) in Sri Lanka in 2000 to that in 2005?
Ensure brevity in your answer.  0.99. What is the ratio of the Population (in %) in Latin America(developing only) in 2000 to that in 2006?
Provide a succinct answer. 0.97. What is the ratio of the Population (in %) in Benin in 2000 to that in 2006?
Your answer should be compact. 0.98. What is the ratio of the Population (in %) in Canada in 2000 to that in 2006?
Your answer should be compact. 0.98. What is the ratio of the Population (in %) in Sri Lanka in 2000 to that in 2006?
Your answer should be compact. 0.99. What is the ratio of the Population (in %) in Latin America(developing only) in 2000 to that in 2007?
Offer a very short reply. 0.97. What is the ratio of the Population (in %) in Benin in 2000 to that in 2007?
Your answer should be very brief. 0.98. What is the ratio of the Population (in %) of Canada in 2000 to that in 2007?
Keep it short and to the point. 0.98. What is the ratio of the Population (in %) in Latin America(developing only) in 2001 to that in 2002?
Provide a succinct answer. 0.99. What is the ratio of the Population (in %) of Canada in 2001 to that in 2002?
Keep it short and to the point. 1. What is the ratio of the Population (in %) in Sri Lanka in 2001 to that in 2002?
Provide a succinct answer. 1. What is the ratio of the Population (in %) in Latin America(developing only) in 2001 to that in 2003?
Your answer should be very brief. 0.99. What is the ratio of the Population (in %) in Canada in 2001 to that in 2003?
Your answer should be very brief. 0.99. What is the ratio of the Population (in %) of Sri Lanka in 2001 to that in 2003?
Offer a very short reply. 1. What is the ratio of the Population (in %) of Latin America(developing only) in 2001 to that in 2004?
Give a very brief answer. 0.99. What is the ratio of the Population (in %) of Benin in 2001 to that in 2004?
Your response must be concise. 0.99. What is the ratio of the Population (in %) of Canada in 2001 to that in 2004?
Provide a short and direct response. 0.99. What is the ratio of the Population (in %) of Latin America(developing only) in 2001 to that in 2005?
Offer a very short reply. 0.98. What is the ratio of the Population (in %) of Benin in 2001 to that in 2005?
Provide a short and direct response. 0.98. What is the ratio of the Population (in %) in Sri Lanka in 2001 to that in 2005?
Keep it short and to the point. 1. What is the ratio of the Population (in %) in Latin America(developing only) in 2001 to that in 2006?
Provide a short and direct response. 0.98. What is the ratio of the Population (in %) of Benin in 2001 to that in 2006?
Make the answer very short. 0.98. What is the ratio of the Population (in %) of Canada in 2001 to that in 2006?
Offer a terse response. 0.99. What is the ratio of the Population (in %) of Latin America(developing only) in 2001 to that in 2007?
Offer a terse response. 0.97. What is the ratio of the Population (in %) in Benin in 2001 to that in 2007?
Offer a very short reply. 0.98. What is the ratio of the Population (in %) of Canada in 2001 to that in 2007?
Your answer should be compact. 0.99. What is the ratio of the Population (in %) of Sri Lanka in 2001 to that in 2007?
Offer a very short reply. 1. What is the ratio of the Population (in %) of Benin in 2002 to that in 2003?
Provide a short and direct response. 1. What is the ratio of the Population (in %) in Canada in 2002 to that in 2003?
Your response must be concise. 1. What is the ratio of the Population (in %) of Sri Lanka in 2002 to that in 2003?
Provide a short and direct response. 1. What is the ratio of the Population (in %) of Latin America(developing only) in 2002 to that in 2004?
Offer a very short reply. 0.99. What is the ratio of the Population (in %) in Benin in 2002 to that in 2004?
Ensure brevity in your answer.  0.99. What is the ratio of the Population (in %) of Canada in 2002 to that in 2004?
Provide a succinct answer. 0.99. What is the ratio of the Population (in %) in Latin America(developing only) in 2002 to that in 2005?
Your response must be concise. 0.99. What is the ratio of the Population (in %) in Benin in 2002 to that in 2005?
Offer a terse response. 0.99. What is the ratio of the Population (in %) of Latin America(developing only) in 2002 to that in 2006?
Your answer should be very brief. 0.98. What is the ratio of the Population (in %) in Benin in 2002 to that in 2006?
Keep it short and to the point. 0.98. What is the ratio of the Population (in %) of Sri Lanka in 2002 to that in 2006?
Your answer should be compact. 1. What is the ratio of the Population (in %) of Latin America(developing only) in 2002 to that in 2007?
Provide a succinct answer. 0.98. What is the ratio of the Population (in %) of Benin in 2002 to that in 2007?
Give a very brief answer. 0.98. What is the ratio of the Population (in %) in Canada in 2002 to that in 2007?
Make the answer very short. 0.99. What is the ratio of the Population (in %) of Latin America(developing only) in 2003 to that in 2004?
Your response must be concise. 1. What is the ratio of the Population (in %) of Benin in 2003 to that in 2004?
Keep it short and to the point. 1. What is the ratio of the Population (in %) of Canada in 2003 to that in 2004?
Offer a very short reply. 1. What is the ratio of the Population (in %) in Sri Lanka in 2003 to that in 2004?
Your answer should be very brief. 1. What is the ratio of the Population (in %) of Benin in 2003 to that in 2005?
Offer a terse response. 0.99. What is the ratio of the Population (in %) in Canada in 2003 to that in 2005?
Offer a terse response. 1. What is the ratio of the Population (in %) of Latin America(developing only) in 2003 to that in 2006?
Make the answer very short. 0.99. What is the ratio of the Population (in %) in Benin in 2003 to that in 2006?
Make the answer very short. 0.99. What is the ratio of the Population (in %) of Canada in 2003 to that in 2006?
Provide a succinct answer. 0.99. What is the ratio of the Population (in %) of Sri Lanka in 2003 to that in 2006?
Keep it short and to the point. 1. What is the ratio of the Population (in %) of Latin America(developing only) in 2003 to that in 2007?
Make the answer very short. 0.98. What is the ratio of the Population (in %) in Benin in 2003 to that in 2007?
Your response must be concise. 0.99. What is the ratio of the Population (in %) in Benin in 2004 to that in 2005?
Provide a short and direct response. 0.99. What is the ratio of the Population (in %) of Canada in 2004 to that in 2005?
Provide a short and direct response. 1. What is the ratio of the Population (in %) in Latin America(developing only) in 2004 to that in 2006?
Keep it short and to the point. 0.99. What is the ratio of the Population (in %) in Canada in 2004 to that in 2006?
Give a very brief answer. 1. What is the ratio of the Population (in %) of Sri Lanka in 2004 to that in 2006?
Provide a short and direct response. 1. What is the ratio of the Population (in %) of Latin America(developing only) in 2004 to that in 2007?
Make the answer very short. 0.99. What is the ratio of the Population (in %) in Benin in 2004 to that in 2007?
Offer a very short reply. 0.99. What is the ratio of the Population (in %) in Canada in 2004 to that in 2007?
Provide a short and direct response. 0.99. What is the ratio of the Population (in %) of Latin America(developing only) in 2005 to that in 2006?
Give a very brief answer. 0.99. What is the ratio of the Population (in %) of Benin in 2005 to that in 2006?
Offer a very short reply. 1. What is the ratio of the Population (in %) in Latin America(developing only) in 2005 to that in 2007?
Offer a very short reply. 0.99. What is the ratio of the Population (in %) of Benin in 2005 to that in 2007?
Make the answer very short. 0.99. What is the ratio of the Population (in %) in Benin in 2006 to that in 2007?
Your answer should be compact. 1. What is the ratio of the Population (in %) in Canada in 2006 to that in 2007?
Ensure brevity in your answer.  1. What is the ratio of the Population (in %) of Sri Lanka in 2006 to that in 2007?
Give a very brief answer. 1. What is the difference between the highest and the second highest Population (in %) in Latin America(developing only)?
Your answer should be very brief. 0.32. What is the difference between the highest and the second highest Population (in %) in Benin?
Make the answer very short. 0.17. What is the difference between the highest and the second highest Population (in %) of Canada?
Give a very brief answer. 0.1. What is the difference between the highest and the second highest Population (in %) in Sri Lanka?
Provide a succinct answer. 0.02. What is the difference between the highest and the lowest Population (in %) in Latin America(developing only)?
Offer a terse response. 2.2. What is the difference between the highest and the lowest Population (in %) in Benin?
Your answer should be compact. 1.3. What is the difference between the highest and the lowest Population (in %) of Canada?
Keep it short and to the point. 1.16. What is the difference between the highest and the lowest Population (in %) of Sri Lanka?
Offer a terse response. 0.54. 